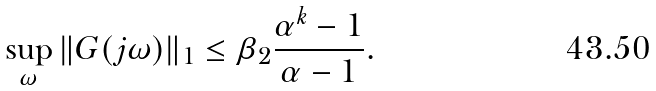Convert formula to latex. <formula><loc_0><loc_0><loc_500><loc_500>\sup _ { \omega } \| G ( j \omega ) \| _ { 1 } \leq \beta _ { 2 } \frac { \alpha ^ { k } - 1 } { \alpha - 1 } .</formula> 